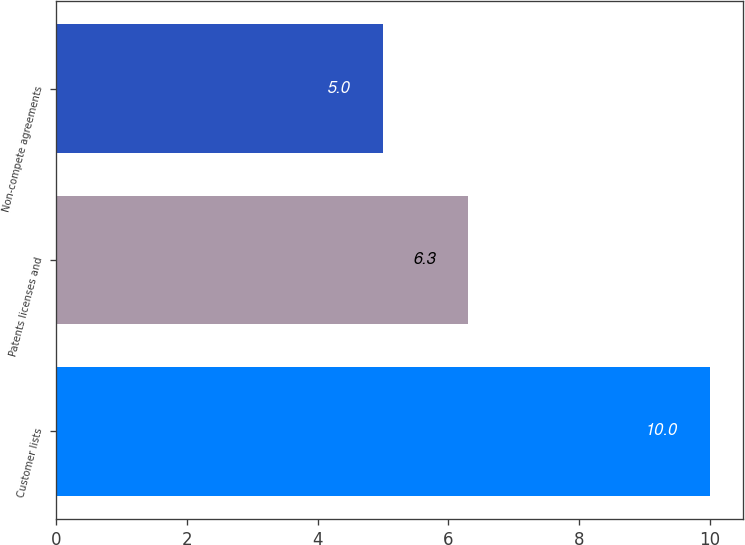<chart> <loc_0><loc_0><loc_500><loc_500><bar_chart><fcel>Customer lists<fcel>Patents licenses and<fcel>Non-compete agreements<nl><fcel>10<fcel>6.3<fcel>5<nl></chart> 